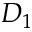Convert formula to latex. <formula><loc_0><loc_0><loc_500><loc_500>D _ { 1 }</formula> 